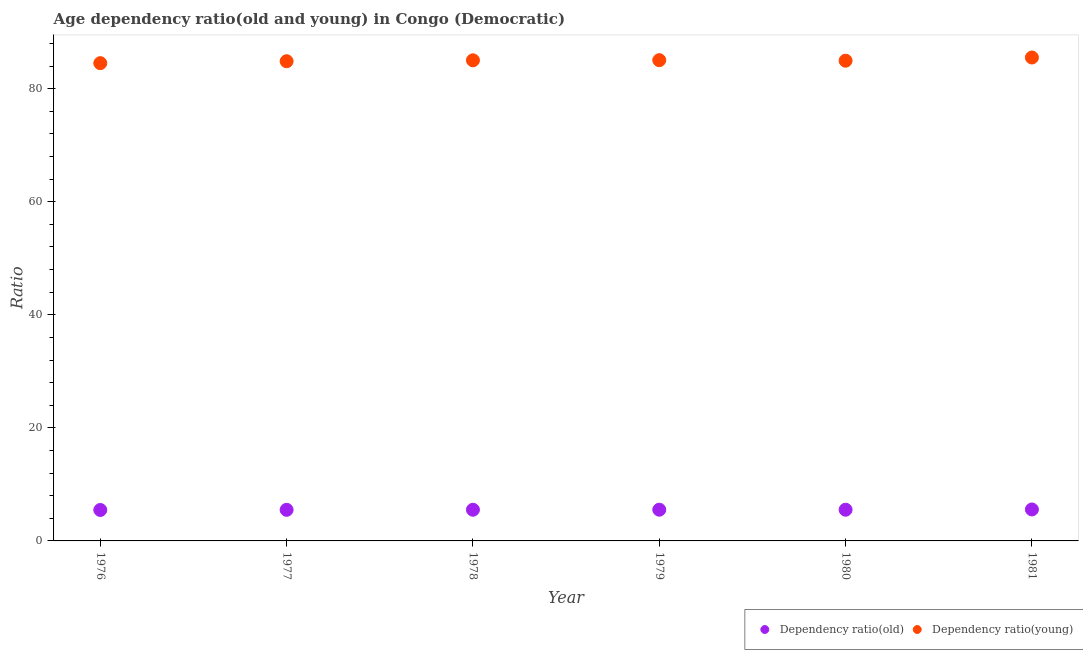How many different coloured dotlines are there?
Provide a succinct answer. 2. Is the number of dotlines equal to the number of legend labels?
Offer a terse response. Yes. What is the age dependency ratio(old) in 1977?
Provide a succinct answer. 5.5. Across all years, what is the maximum age dependency ratio(old)?
Provide a short and direct response. 5.57. Across all years, what is the minimum age dependency ratio(old)?
Ensure brevity in your answer.  5.47. In which year was the age dependency ratio(young) maximum?
Give a very brief answer. 1981. In which year was the age dependency ratio(young) minimum?
Give a very brief answer. 1976. What is the total age dependency ratio(old) in the graph?
Give a very brief answer. 33.1. What is the difference between the age dependency ratio(young) in 1977 and that in 1979?
Provide a short and direct response. -0.19. What is the difference between the age dependency ratio(old) in 1978 and the age dependency ratio(young) in 1977?
Provide a succinct answer. -79.33. What is the average age dependency ratio(old) per year?
Keep it short and to the point. 5.52. In the year 1978, what is the difference between the age dependency ratio(old) and age dependency ratio(young)?
Offer a terse response. -79.49. In how many years, is the age dependency ratio(young) greater than 76?
Your answer should be very brief. 6. What is the ratio of the age dependency ratio(old) in 1978 to that in 1979?
Provide a short and direct response. 1. Is the age dependency ratio(young) in 1979 less than that in 1981?
Give a very brief answer. Yes. Is the difference between the age dependency ratio(young) in 1978 and 1980 greater than the difference between the age dependency ratio(old) in 1978 and 1980?
Your answer should be compact. Yes. What is the difference between the highest and the second highest age dependency ratio(young)?
Make the answer very short. 0.47. What is the difference between the highest and the lowest age dependency ratio(old)?
Offer a very short reply. 0.09. Is the sum of the age dependency ratio(old) in 1978 and 1980 greater than the maximum age dependency ratio(young) across all years?
Make the answer very short. No. Is the age dependency ratio(old) strictly greater than the age dependency ratio(young) over the years?
Your response must be concise. No. Is the age dependency ratio(old) strictly less than the age dependency ratio(young) over the years?
Make the answer very short. Yes. How many dotlines are there?
Give a very brief answer. 2. How many years are there in the graph?
Your answer should be compact. 6. What is the difference between two consecutive major ticks on the Y-axis?
Keep it short and to the point. 20. Are the values on the major ticks of Y-axis written in scientific E-notation?
Give a very brief answer. No. Where does the legend appear in the graph?
Your response must be concise. Bottom right. How many legend labels are there?
Ensure brevity in your answer.  2. How are the legend labels stacked?
Provide a short and direct response. Horizontal. What is the title of the graph?
Ensure brevity in your answer.  Age dependency ratio(old and young) in Congo (Democratic). Does "DAC donors" appear as one of the legend labels in the graph?
Ensure brevity in your answer.  No. What is the label or title of the Y-axis?
Make the answer very short. Ratio. What is the Ratio in Dependency ratio(old) in 1976?
Give a very brief answer. 5.47. What is the Ratio of Dependency ratio(young) in 1976?
Offer a terse response. 84.51. What is the Ratio of Dependency ratio(old) in 1977?
Offer a terse response. 5.5. What is the Ratio in Dependency ratio(young) in 1977?
Keep it short and to the point. 84.85. What is the Ratio in Dependency ratio(old) in 1978?
Your answer should be very brief. 5.52. What is the Ratio in Dependency ratio(young) in 1978?
Your response must be concise. 85.01. What is the Ratio in Dependency ratio(old) in 1979?
Provide a succinct answer. 5.52. What is the Ratio in Dependency ratio(young) in 1979?
Give a very brief answer. 85.04. What is the Ratio of Dependency ratio(old) in 1980?
Make the answer very short. 5.52. What is the Ratio of Dependency ratio(young) in 1980?
Ensure brevity in your answer.  84.94. What is the Ratio of Dependency ratio(old) in 1981?
Keep it short and to the point. 5.57. What is the Ratio of Dependency ratio(young) in 1981?
Provide a succinct answer. 85.51. Across all years, what is the maximum Ratio of Dependency ratio(old)?
Offer a very short reply. 5.57. Across all years, what is the maximum Ratio in Dependency ratio(young)?
Ensure brevity in your answer.  85.51. Across all years, what is the minimum Ratio in Dependency ratio(old)?
Your answer should be very brief. 5.47. Across all years, what is the minimum Ratio of Dependency ratio(young)?
Your answer should be compact. 84.51. What is the total Ratio of Dependency ratio(old) in the graph?
Give a very brief answer. 33.1. What is the total Ratio in Dependency ratio(young) in the graph?
Provide a short and direct response. 509.85. What is the difference between the Ratio of Dependency ratio(old) in 1976 and that in 1977?
Offer a very short reply. -0.03. What is the difference between the Ratio of Dependency ratio(young) in 1976 and that in 1977?
Offer a terse response. -0.34. What is the difference between the Ratio in Dependency ratio(old) in 1976 and that in 1978?
Your answer should be compact. -0.04. What is the difference between the Ratio in Dependency ratio(young) in 1976 and that in 1978?
Your answer should be very brief. -0.5. What is the difference between the Ratio of Dependency ratio(old) in 1976 and that in 1979?
Ensure brevity in your answer.  -0.05. What is the difference between the Ratio of Dependency ratio(young) in 1976 and that in 1979?
Provide a short and direct response. -0.53. What is the difference between the Ratio in Dependency ratio(old) in 1976 and that in 1980?
Keep it short and to the point. -0.04. What is the difference between the Ratio of Dependency ratio(young) in 1976 and that in 1980?
Offer a terse response. -0.43. What is the difference between the Ratio in Dependency ratio(old) in 1976 and that in 1981?
Provide a short and direct response. -0.09. What is the difference between the Ratio in Dependency ratio(young) in 1976 and that in 1981?
Offer a very short reply. -1. What is the difference between the Ratio of Dependency ratio(old) in 1977 and that in 1978?
Offer a very short reply. -0.02. What is the difference between the Ratio in Dependency ratio(young) in 1977 and that in 1978?
Your answer should be very brief. -0.16. What is the difference between the Ratio in Dependency ratio(old) in 1977 and that in 1979?
Provide a succinct answer. -0.02. What is the difference between the Ratio of Dependency ratio(young) in 1977 and that in 1979?
Offer a very short reply. -0.19. What is the difference between the Ratio in Dependency ratio(old) in 1977 and that in 1980?
Your answer should be compact. -0.02. What is the difference between the Ratio of Dependency ratio(young) in 1977 and that in 1980?
Give a very brief answer. -0.09. What is the difference between the Ratio of Dependency ratio(old) in 1977 and that in 1981?
Ensure brevity in your answer.  -0.07. What is the difference between the Ratio of Dependency ratio(young) in 1977 and that in 1981?
Offer a very short reply. -0.66. What is the difference between the Ratio of Dependency ratio(old) in 1978 and that in 1979?
Keep it short and to the point. -0. What is the difference between the Ratio in Dependency ratio(young) in 1978 and that in 1979?
Keep it short and to the point. -0.03. What is the difference between the Ratio of Dependency ratio(old) in 1978 and that in 1980?
Offer a very short reply. -0. What is the difference between the Ratio of Dependency ratio(young) in 1978 and that in 1980?
Give a very brief answer. 0.07. What is the difference between the Ratio in Dependency ratio(young) in 1978 and that in 1981?
Your answer should be compact. -0.5. What is the difference between the Ratio in Dependency ratio(old) in 1979 and that in 1980?
Offer a very short reply. 0. What is the difference between the Ratio of Dependency ratio(young) in 1979 and that in 1980?
Offer a terse response. 0.1. What is the difference between the Ratio in Dependency ratio(old) in 1979 and that in 1981?
Offer a terse response. -0.05. What is the difference between the Ratio of Dependency ratio(young) in 1979 and that in 1981?
Provide a short and direct response. -0.47. What is the difference between the Ratio in Dependency ratio(old) in 1980 and that in 1981?
Your answer should be compact. -0.05. What is the difference between the Ratio of Dependency ratio(young) in 1980 and that in 1981?
Make the answer very short. -0.57. What is the difference between the Ratio in Dependency ratio(old) in 1976 and the Ratio in Dependency ratio(young) in 1977?
Your answer should be very brief. -79.38. What is the difference between the Ratio of Dependency ratio(old) in 1976 and the Ratio of Dependency ratio(young) in 1978?
Give a very brief answer. -79.54. What is the difference between the Ratio in Dependency ratio(old) in 1976 and the Ratio in Dependency ratio(young) in 1979?
Ensure brevity in your answer.  -79.56. What is the difference between the Ratio in Dependency ratio(old) in 1976 and the Ratio in Dependency ratio(young) in 1980?
Your answer should be very brief. -79.47. What is the difference between the Ratio of Dependency ratio(old) in 1976 and the Ratio of Dependency ratio(young) in 1981?
Provide a succinct answer. -80.04. What is the difference between the Ratio of Dependency ratio(old) in 1977 and the Ratio of Dependency ratio(young) in 1978?
Ensure brevity in your answer.  -79.51. What is the difference between the Ratio of Dependency ratio(old) in 1977 and the Ratio of Dependency ratio(young) in 1979?
Your answer should be compact. -79.53. What is the difference between the Ratio in Dependency ratio(old) in 1977 and the Ratio in Dependency ratio(young) in 1980?
Make the answer very short. -79.44. What is the difference between the Ratio in Dependency ratio(old) in 1977 and the Ratio in Dependency ratio(young) in 1981?
Offer a terse response. -80.01. What is the difference between the Ratio of Dependency ratio(old) in 1978 and the Ratio of Dependency ratio(young) in 1979?
Offer a very short reply. -79.52. What is the difference between the Ratio of Dependency ratio(old) in 1978 and the Ratio of Dependency ratio(young) in 1980?
Your answer should be compact. -79.42. What is the difference between the Ratio in Dependency ratio(old) in 1978 and the Ratio in Dependency ratio(young) in 1981?
Ensure brevity in your answer.  -79.99. What is the difference between the Ratio in Dependency ratio(old) in 1979 and the Ratio in Dependency ratio(young) in 1980?
Your response must be concise. -79.42. What is the difference between the Ratio in Dependency ratio(old) in 1979 and the Ratio in Dependency ratio(young) in 1981?
Offer a terse response. -79.99. What is the difference between the Ratio in Dependency ratio(old) in 1980 and the Ratio in Dependency ratio(young) in 1981?
Provide a short and direct response. -79.99. What is the average Ratio in Dependency ratio(old) per year?
Provide a short and direct response. 5.52. What is the average Ratio of Dependency ratio(young) per year?
Provide a short and direct response. 84.98. In the year 1976, what is the difference between the Ratio in Dependency ratio(old) and Ratio in Dependency ratio(young)?
Give a very brief answer. -79.04. In the year 1977, what is the difference between the Ratio in Dependency ratio(old) and Ratio in Dependency ratio(young)?
Your response must be concise. -79.35. In the year 1978, what is the difference between the Ratio of Dependency ratio(old) and Ratio of Dependency ratio(young)?
Provide a succinct answer. -79.49. In the year 1979, what is the difference between the Ratio of Dependency ratio(old) and Ratio of Dependency ratio(young)?
Offer a terse response. -79.51. In the year 1980, what is the difference between the Ratio in Dependency ratio(old) and Ratio in Dependency ratio(young)?
Ensure brevity in your answer.  -79.42. In the year 1981, what is the difference between the Ratio of Dependency ratio(old) and Ratio of Dependency ratio(young)?
Give a very brief answer. -79.94. What is the ratio of the Ratio in Dependency ratio(old) in 1976 to that in 1977?
Make the answer very short. 0.99. What is the ratio of the Ratio in Dependency ratio(young) in 1976 to that in 1977?
Provide a succinct answer. 1. What is the ratio of the Ratio of Dependency ratio(old) in 1976 to that in 1978?
Provide a short and direct response. 0.99. What is the ratio of the Ratio in Dependency ratio(young) in 1976 to that in 1978?
Offer a terse response. 0.99. What is the ratio of the Ratio in Dependency ratio(old) in 1976 to that in 1979?
Make the answer very short. 0.99. What is the ratio of the Ratio of Dependency ratio(old) in 1976 to that in 1980?
Make the answer very short. 0.99. What is the ratio of the Ratio of Dependency ratio(young) in 1976 to that in 1980?
Offer a terse response. 0.99. What is the ratio of the Ratio in Dependency ratio(old) in 1976 to that in 1981?
Provide a succinct answer. 0.98. What is the ratio of the Ratio in Dependency ratio(young) in 1976 to that in 1981?
Provide a succinct answer. 0.99. What is the ratio of the Ratio of Dependency ratio(young) in 1977 to that in 1978?
Your answer should be very brief. 1. What is the ratio of the Ratio in Dependency ratio(young) in 1977 to that in 1980?
Make the answer very short. 1. What is the ratio of the Ratio in Dependency ratio(old) in 1977 to that in 1981?
Your response must be concise. 0.99. What is the ratio of the Ratio in Dependency ratio(old) in 1978 to that in 1979?
Give a very brief answer. 1. What is the ratio of the Ratio in Dependency ratio(old) in 1978 to that in 1980?
Provide a short and direct response. 1. What is the ratio of the Ratio of Dependency ratio(young) in 1978 to that in 1980?
Offer a very short reply. 1. What is the ratio of the Ratio in Dependency ratio(old) in 1978 to that in 1981?
Your answer should be compact. 0.99. What is the ratio of the Ratio in Dependency ratio(old) in 1979 to that in 1980?
Your response must be concise. 1. What is the ratio of the Ratio of Dependency ratio(old) in 1979 to that in 1981?
Your answer should be compact. 0.99. What is the ratio of the Ratio in Dependency ratio(young) in 1979 to that in 1981?
Your answer should be compact. 0.99. What is the ratio of the Ratio of Dependency ratio(young) in 1980 to that in 1981?
Your response must be concise. 0.99. What is the difference between the highest and the second highest Ratio in Dependency ratio(old)?
Your answer should be very brief. 0.05. What is the difference between the highest and the second highest Ratio of Dependency ratio(young)?
Your answer should be compact. 0.47. What is the difference between the highest and the lowest Ratio of Dependency ratio(old)?
Your answer should be very brief. 0.09. What is the difference between the highest and the lowest Ratio of Dependency ratio(young)?
Provide a succinct answer. 1. 